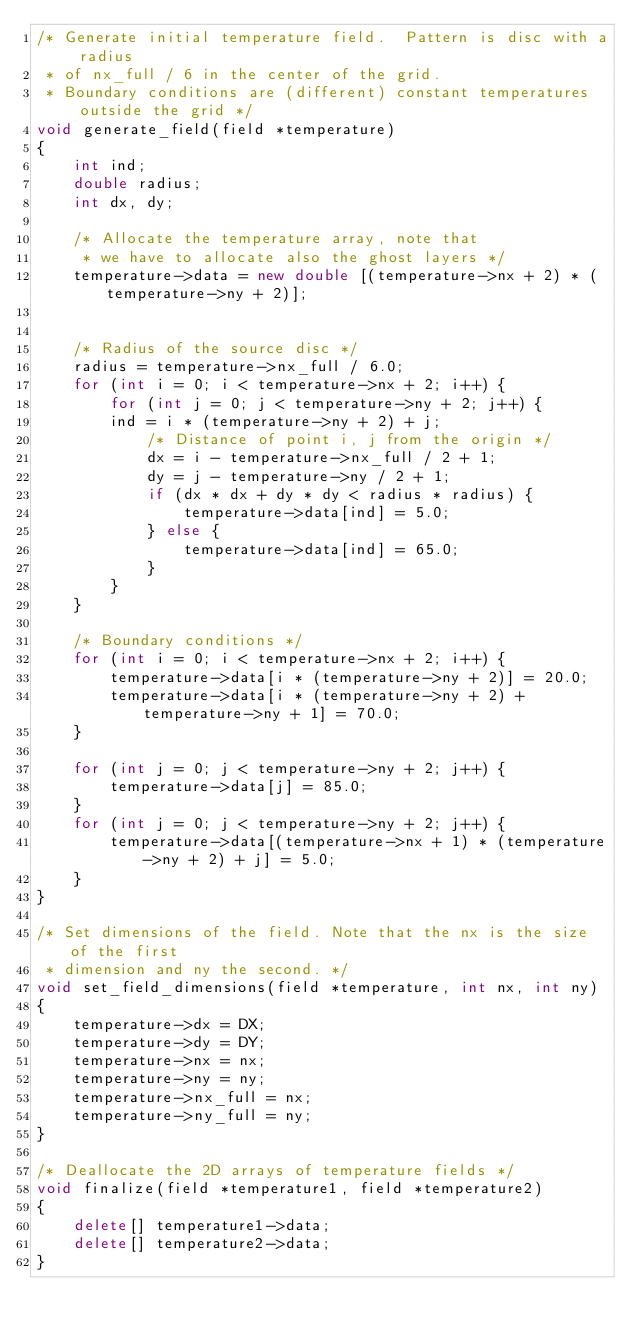Convert code to text. <code><loc_0><loc_0><loc_500><loc_500><_C++_>/* Generate initial temperature field.  Pattern is disc with a radius
 * of nx_full / 6 in the center of the grid.
 * Boundary conditions are (different) constant temperatures outside the grid */
void generate_field(field *temperature)
{
    int ind;
    double radius;
    int dx, dy;

    /* Allocate the temperature array, note that
     * we have to allocate also the ghost layers */
    temperature->data = new double [(temperature->nx + 2) * (temperature->ny + 2)];


    /* Radius of the source disc */
    radius = temperature->nx_full / 6.0;
    for (int i = 0; i < temperature->nx + 2; i++) {
        for (int j = 0; j < temperature->ny + 2; j++) {
	    ind = i * (temperature->ny + 2) + j;
            /* Distance of point i, j from the origin */
            dx = i - temperature->nx_full / 2 + 1;
            dy = j - temperature->ny / 2 + 1;
            if (dx * dx + dy * dy < radius * radius) {
                temperature->data[ind] = 5.0;
            } else {
                temperature->data[ind] = 65.0;
            }
        }
    }

    /* Boundary conditions */
    for (int i = 0; i < temperature->nx + 2; i++) {
        temperature->data[i * (temperature->ny + 2)] = 20.0;
        temperature->data[i * (temperature->ny + 2) + temperature->ny + 1] = 70.0;
    }

    for (int j = 0; j < temperature->ny + 2; j++) {
        temperature->data[j] = 85.0;
    }
    for (int j = 0; j < temperature->ny + 2; j++) {
        temperature->data[(temperature->nx + 1) * (temperature->ny + 2) + j] = 5.0;
    }
}

/* Set dimensions of the field. Note that the nx is the size of the first
 * dimension and ny the second. */
void set_field_dimensions(field *temperature, int nx, int ny)
{
    temperature->dx = DX;
    temperature->dy = DY;
    temperature->nx = nx;
    temperature->ny = ny;
    temperature->nx_full = nx;
    temperature->ny_full = ny;
}

/* Deallocate the 2D arrays of temperature fields */
void finalize(field *temperature1, field *temperature2)
{
    delete[] temperature1->data;
    delete[] temperature2->data;
}

</code> 